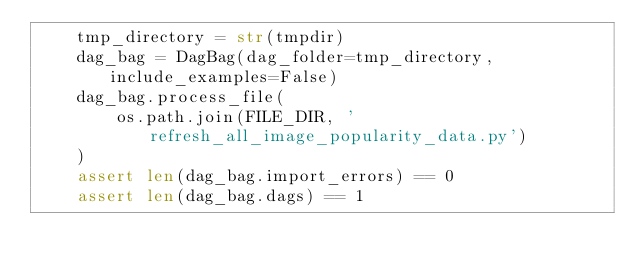Convert code to text. <code><loc_0><loc_0><loc_500><loc_500><_Python_>    tmp_directory = str(tmpdir)
    dag_bag = DagBag(dag_folder=tmp_directory, include_examples=False)
    dag_bag.process_file(
        os.path.join(FILE_DIR, 'refresh_all_image_popularity_data.py')
    )
    assert len(dag_bag.import_errors) == 0
    assert len(dag_bag.dags) == 1
</code> 